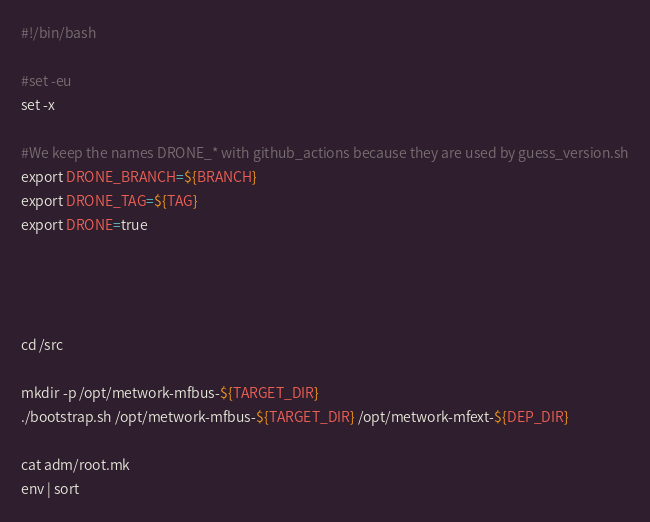<code> <loc_0><loc_0><loc_500><loc_500><_Bash_>#!/bin/bash

#set -eu
set -x

#We keep the names DRONE_* with github_actions because they are used by guess_version.sh
export DRONE_BRANCH=${BRANCH}
export DRONE_TAG=${TAG}
export DRONE=true


    

cd /src

mkdir -p /opt/metwork-mfbus-${TARGET_DIR}
./bootstrap.sh /opt/metwork-mfbus-${TARGET_DIR} /opt/metwork-mfext-${DEP_DIR}

cat adm/root.mk
env | sort
</code> 